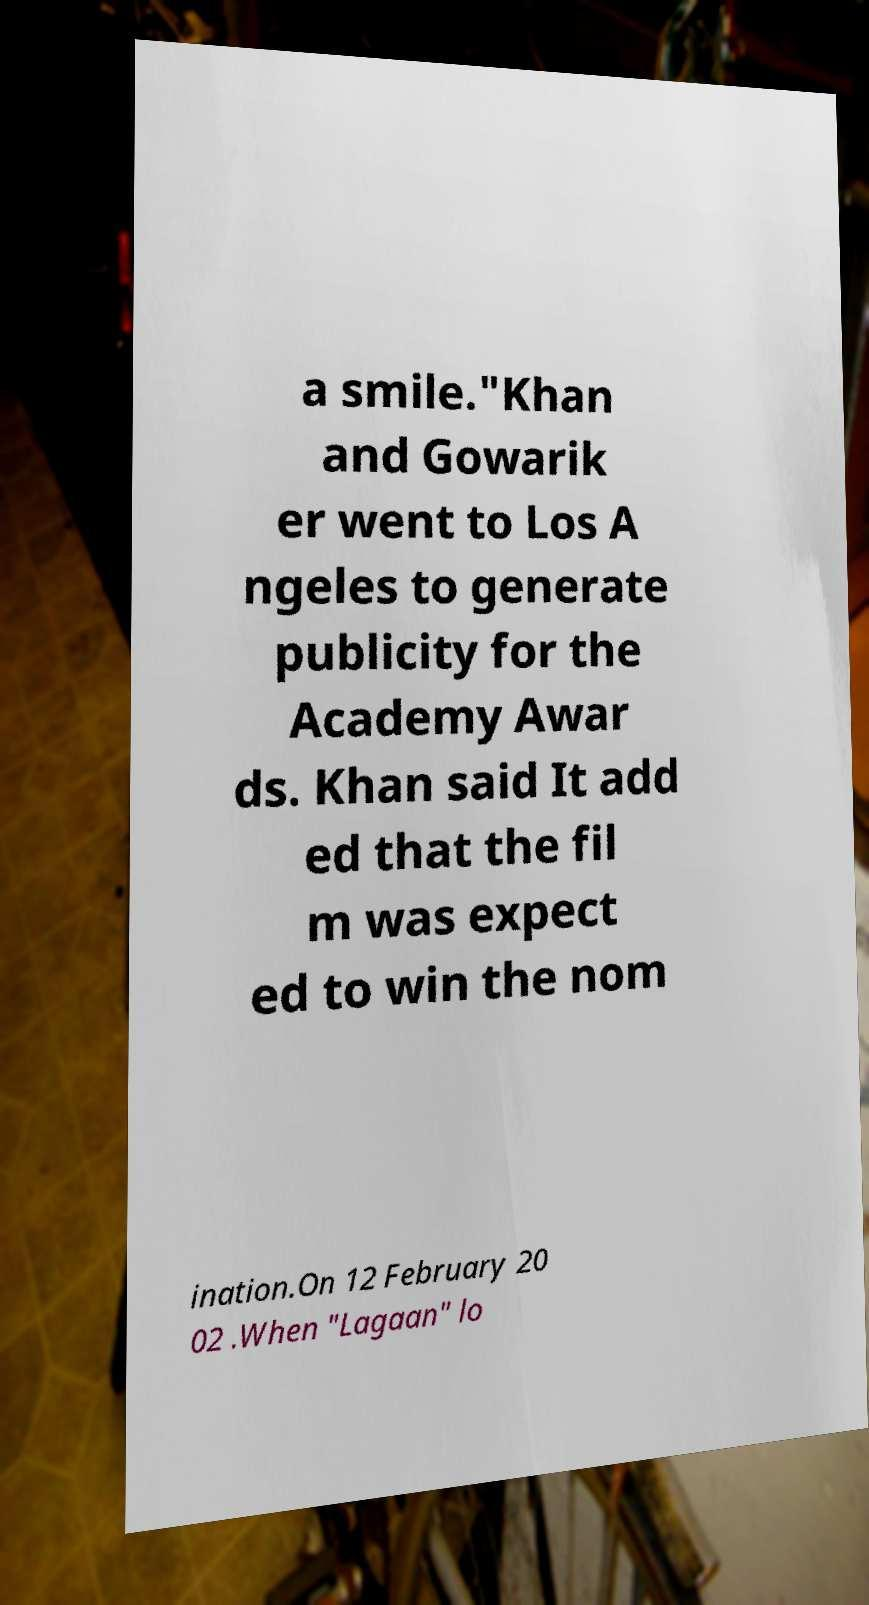What messages or text are displayed in this image? I need them in a readable, typed format. a smile."Khan and Gowarik er went to Los A ngeles to generate publicity for the Academy Awar ds. Khan said It add ed that the fil m was expect ed to win the nom ination.On 12 February 20 02 .When "Lagaan" lo 